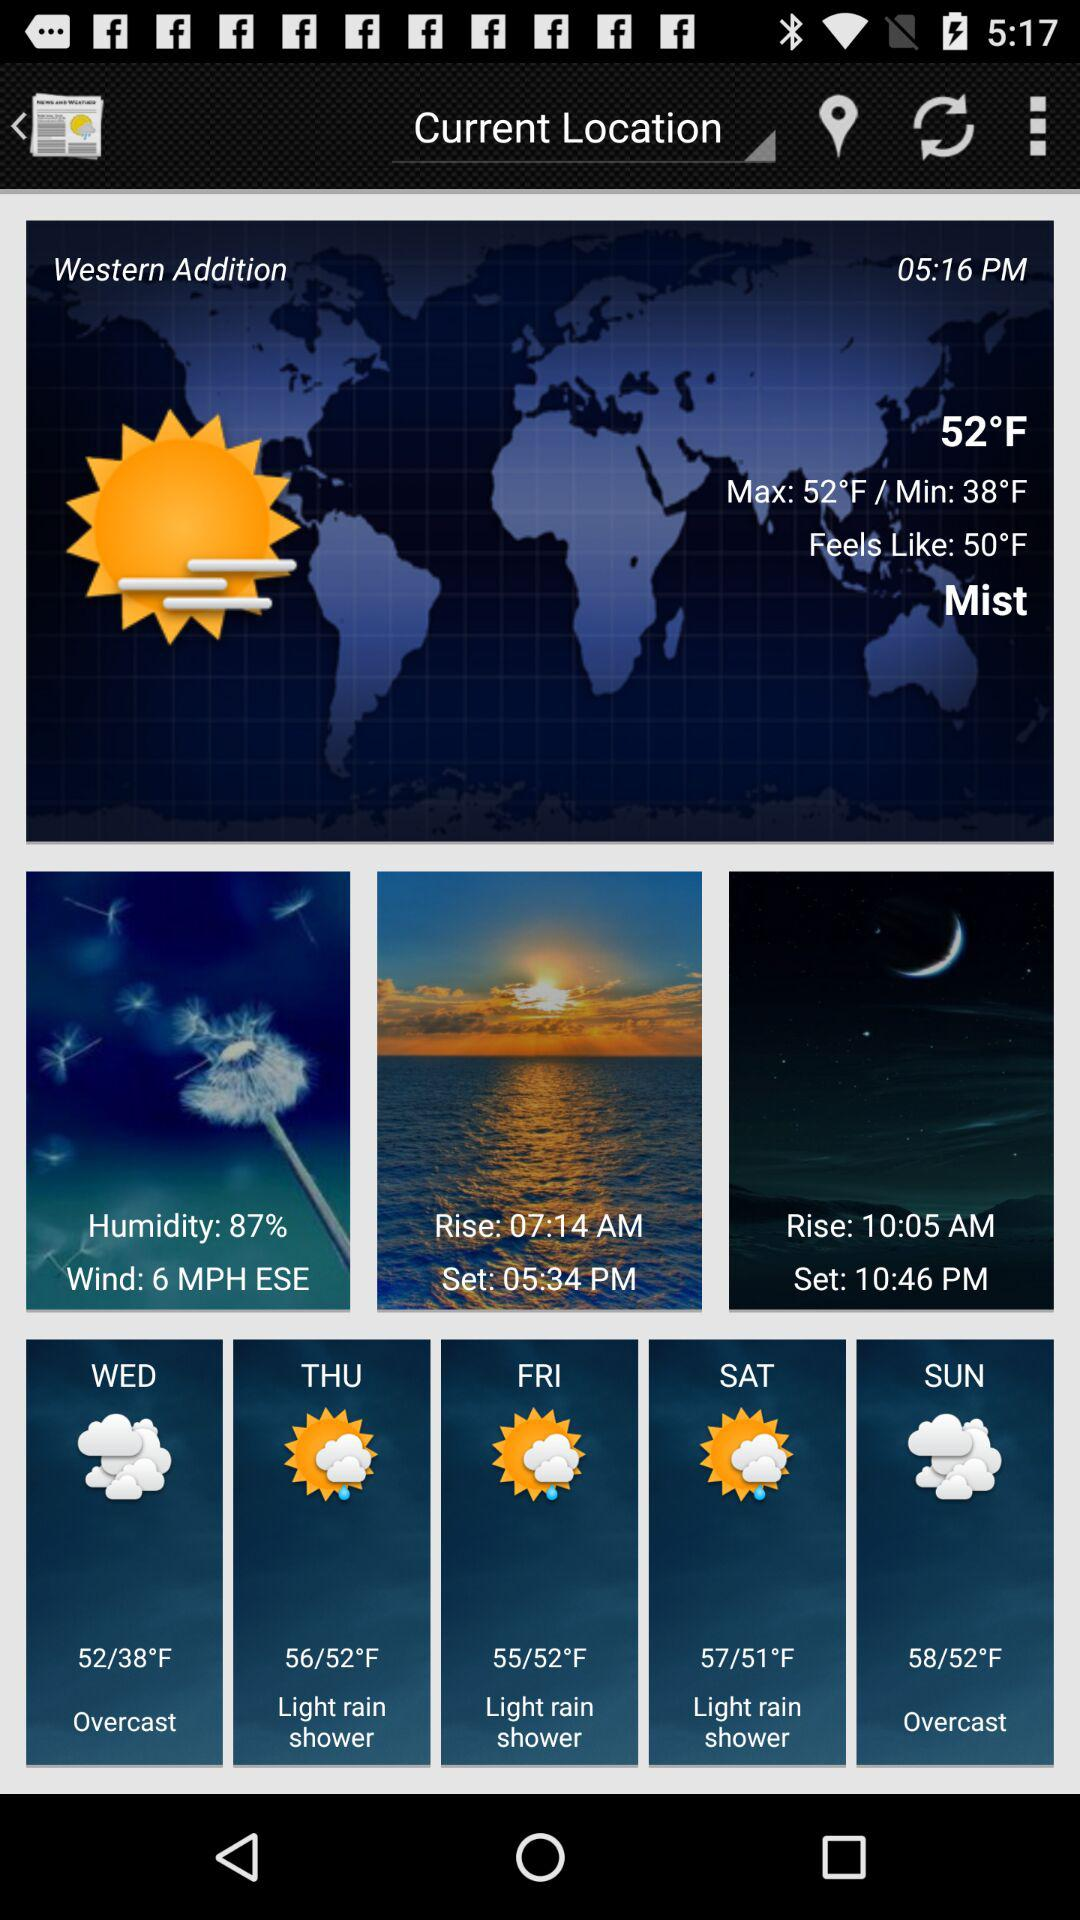How is the weather on Friday? The weather on Friday is a light rain shower. 